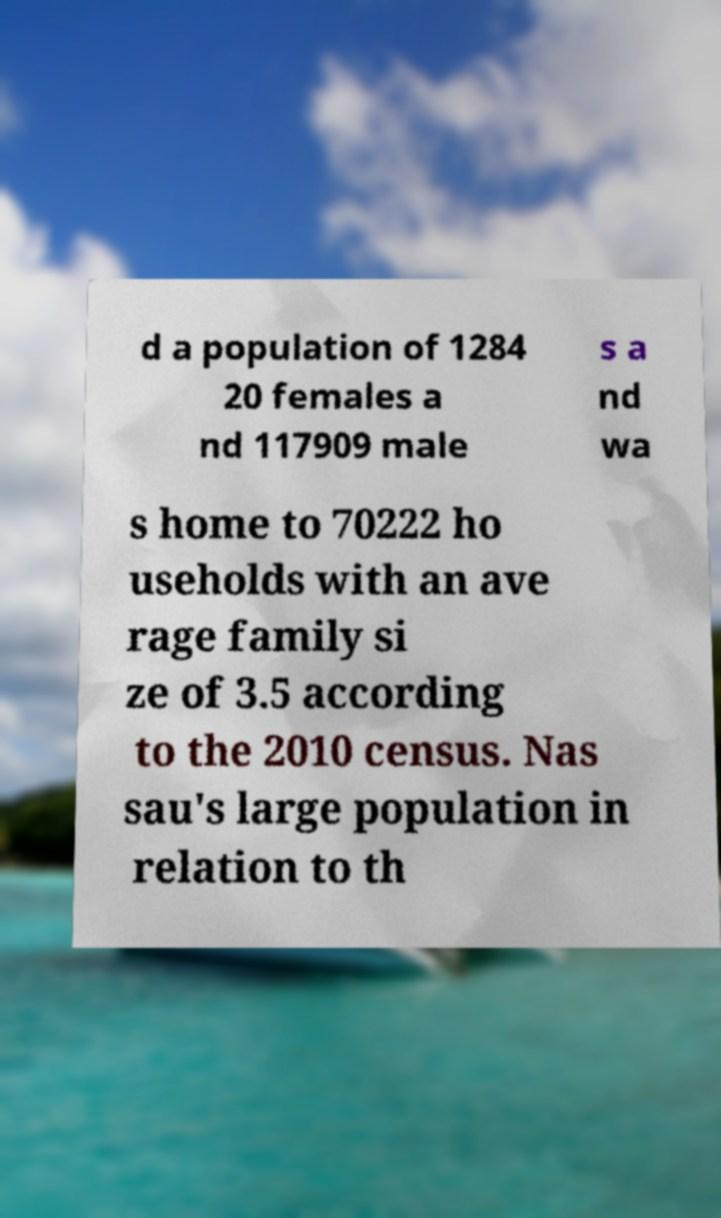Could you assist in decoding the text presented in this image and type it out clearly? d a population of 1284 20 females a nd 117909 male s a nd wa s home to 70222 ho useholds with an ave rage family si ze of 3.5 according to the 2010 census. Nas sau's large population in relation to th 